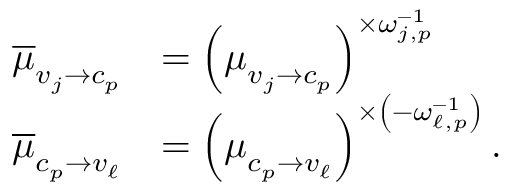Convert formula to latex. <formula><loc_0><loc_0><loc_500><loc_500>\begin{array} { r l } { \overline { \mu } _ { v _ { j } \to c _ { p } } } & { = \left ( \mu _ { v _ { j } \to c _ { p } } \right ) ^ { \times \omega _ { j , p } ^ { - 1 } } } \\ { \overline { \mu } _ { c _ { p } \to v _ { \ell } } } & { = \left ( \mu _ { c _ { p } \to v _ { \ell } } \right ) ^ { \times \left ( - \omega _ { \ell , p } ^ { - 1 } \right ) } . } \end{array}</formula> 